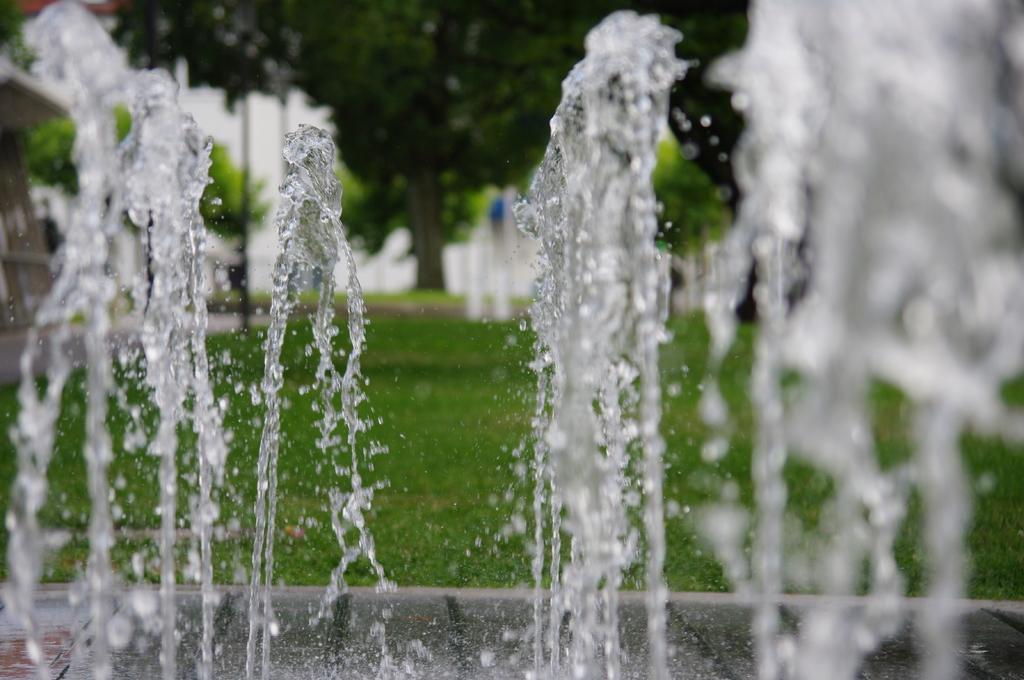How would you summarize this image in a sentence or two? In this picture we can see the fountain. On the right there is a water. In the background we can see the building, trees, plants and grass. 